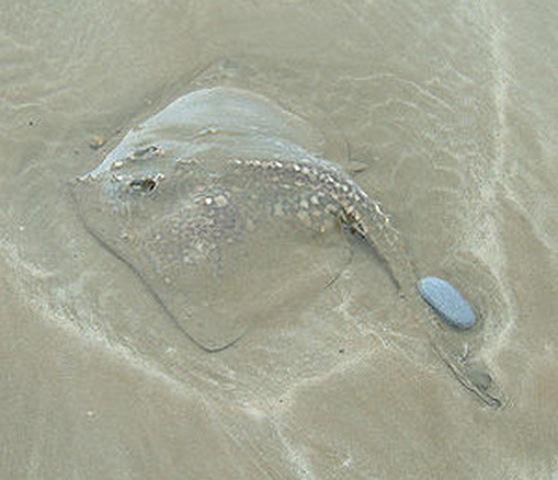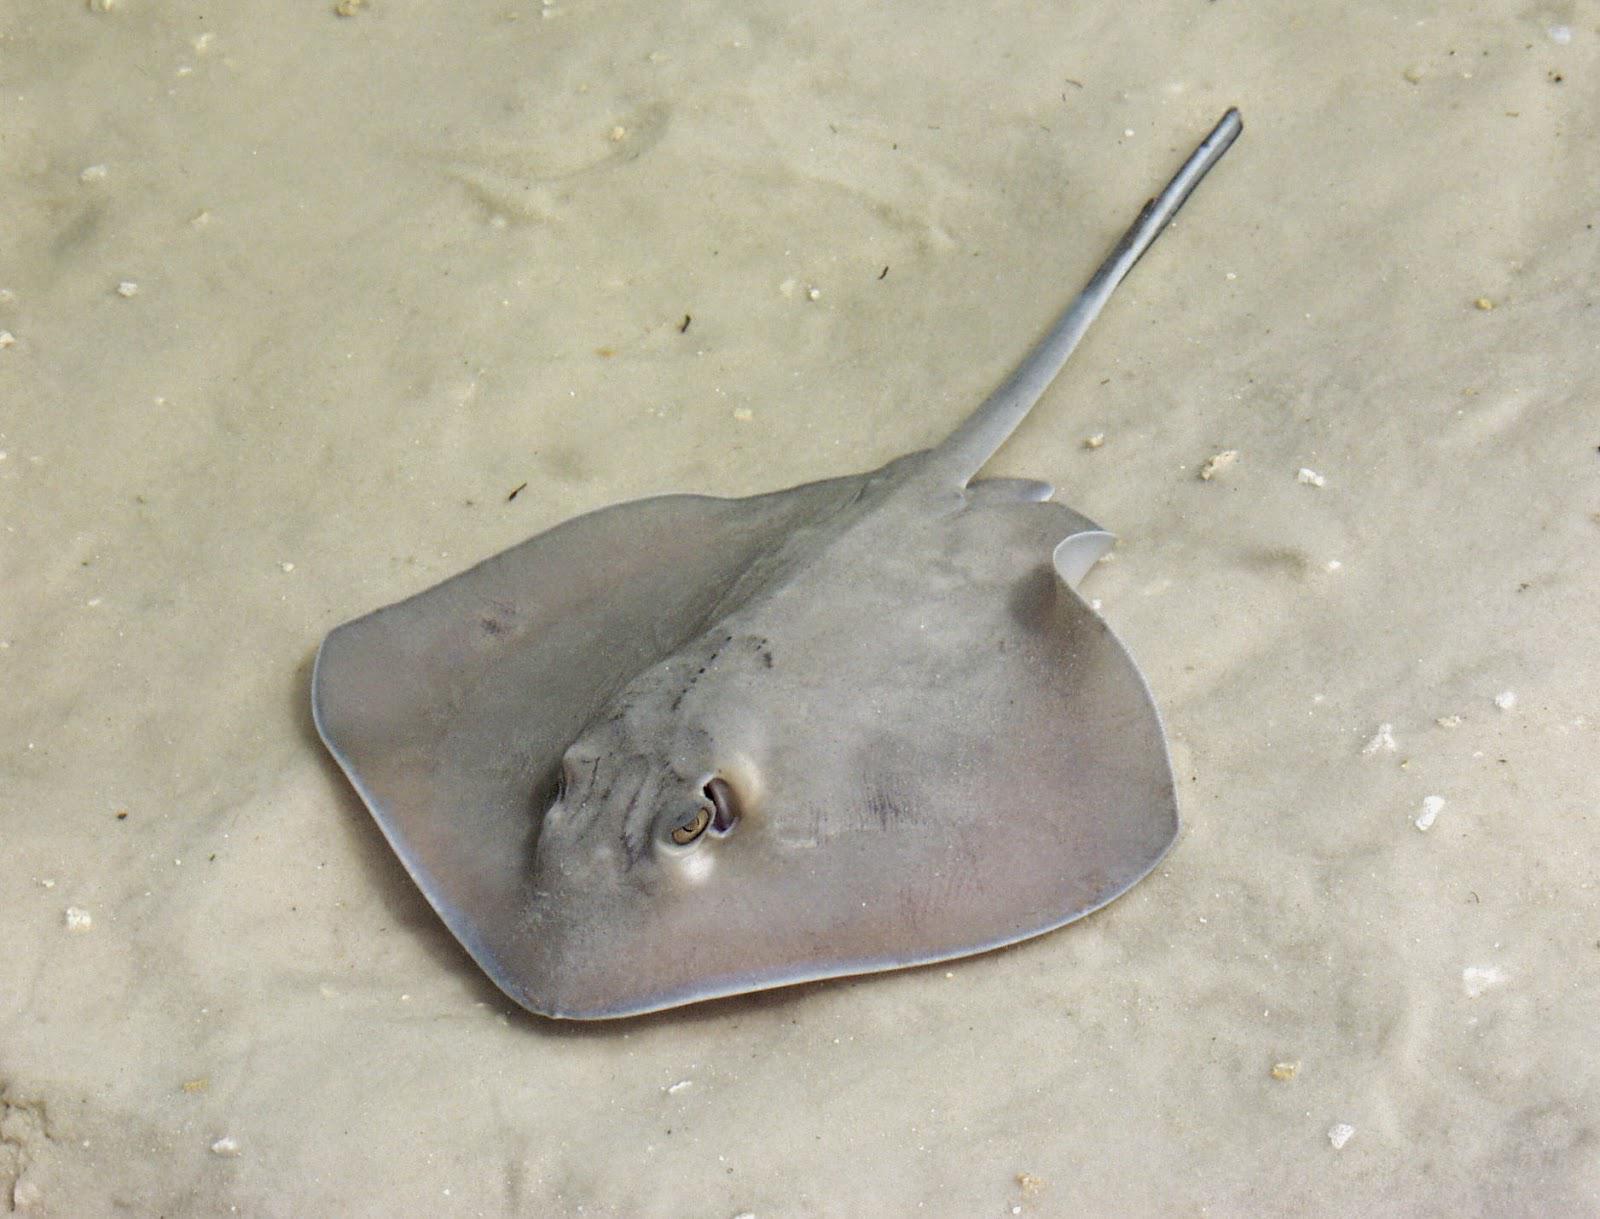The first image is the image on the left, the second image is the image on the right. For the images shown, is this caption "One image shows a camera-facing stingray mostly covered in sand, with black eyes projecting out." true? Answer yes or no. No. The first image is the image on the left, the second image is the image on the right. Given the left and right images, does the statement "All four of the skates are covered partially or nearly entirely by sand." hold true? Answer yes or no. No. 